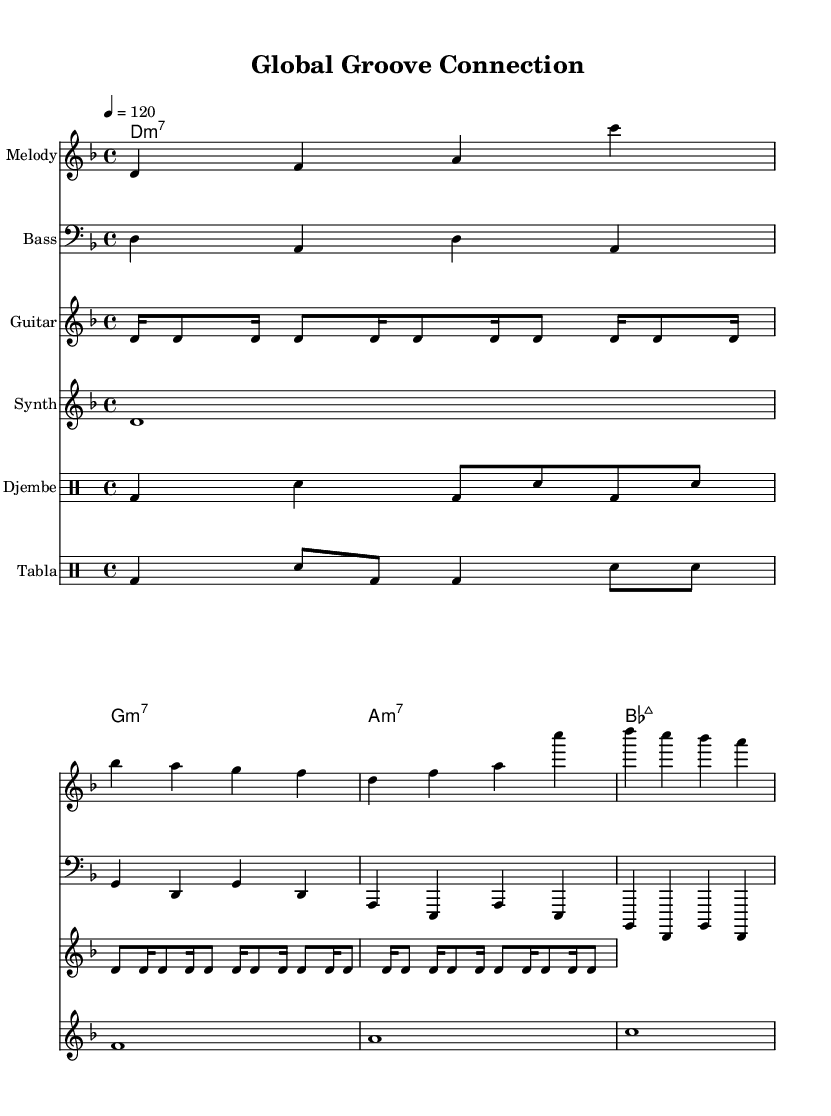What is the key signature of this music? The key signature displayed at the beginning indicates two flats, which is typical for D minor.
Answer: D minor What is the time signature of this music? The time signature is found at the beginning of the sheet music, represented as 4/4, indicating four beats per measure.
Answer: 4/4 What is the tempo marking for this piece? The tempo is indicated at the start as "4 = 120," meaning there are 120 beats per minute, specifically for quarter notes.
Answer: 120 How many measures are in the melody section? By counting the different groups of notes grouped by vertical lines, we can see there are 4 measures in the melody.
Answer: 4 Which instruments are included in this sheet music? The instruments listed at the start of each staff include Melody, Bass, Guitar, Synth, Djembe, and Tabla, indicating a mix of melodic and rhythmic components.
Answer: Melody, Bass, Guitar, Synth, Djembe, Tabla What is the chord progression used in this piece? The chord progression can be found in the chord names staff, which lists D minor 7, G minor 7, A minor 7, and B flat major 7 consecutively.
Answer: D minor 7, G minor 7, A minor 7, B flat major 7 What rhythmic elements distinguish this piece as Funk? The Funk style is highlighted by syncopated rhythms, particularly in the Djembe and Tabla sections which create a groovy feel through their unique beats.
Answer: Syncopation 